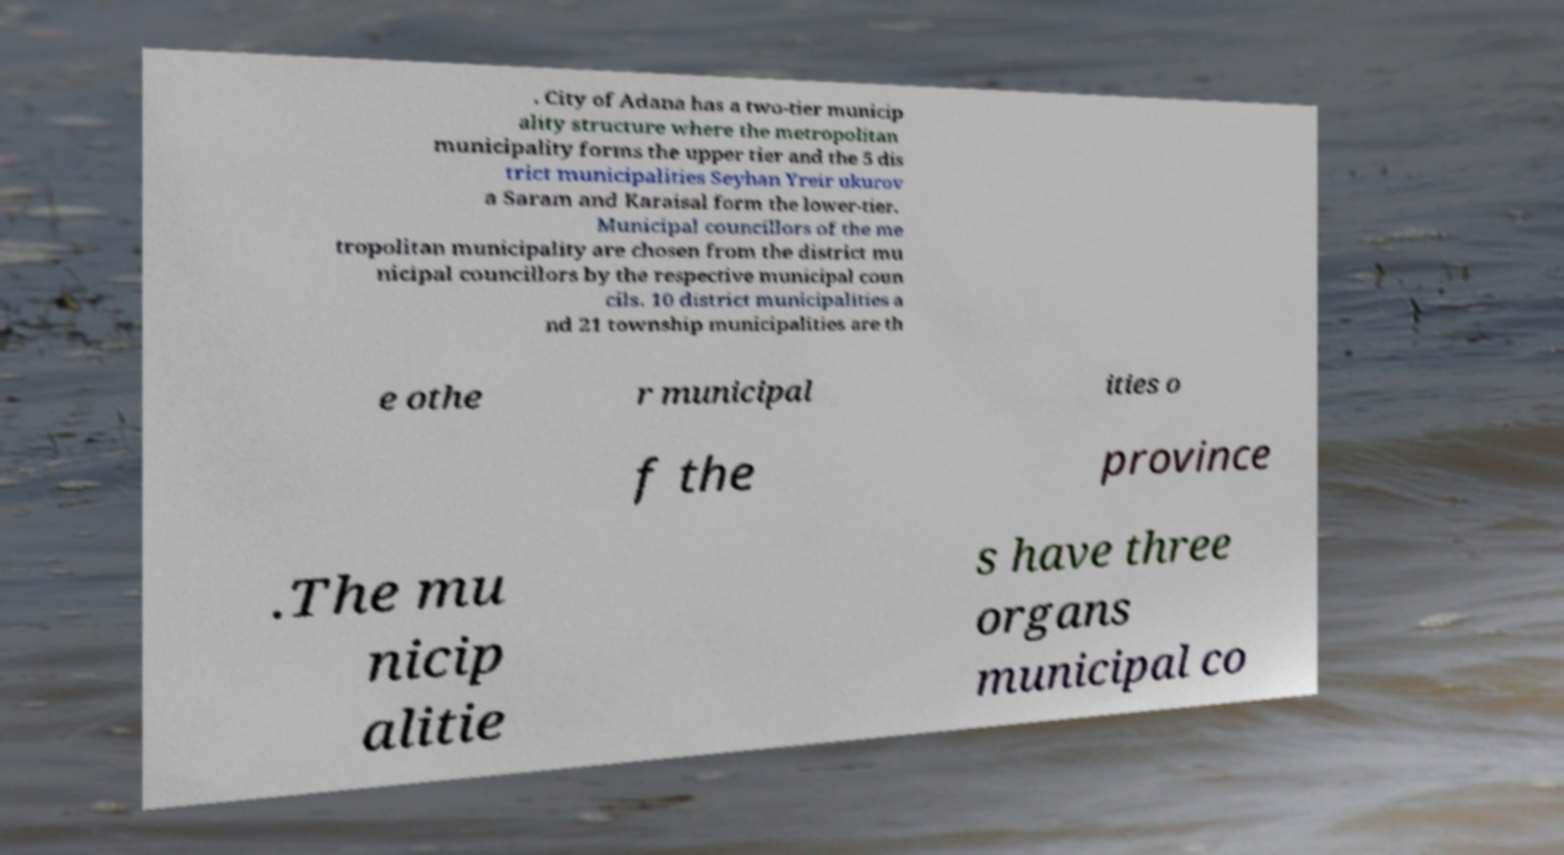There's text embedded in this image that I need extracted. Can you transcribe it verbatim? . City of Adana has a two-tier municip ality structure where the metropolitan municipality forms the upper tier and the 5 dis trict municipalities Seyhan Yreir ukurov a Saram and Karaisal form the lower-tier. Municipal councillors of the me tropolitan municipality are chosen from the district mu nicipal councillors by the respective municipal coun cils. 10 district municipalities a nd 21 township municipalities are th e othe r municipal ities o f the province .The mu nicip alitie s have three organs municipal co 